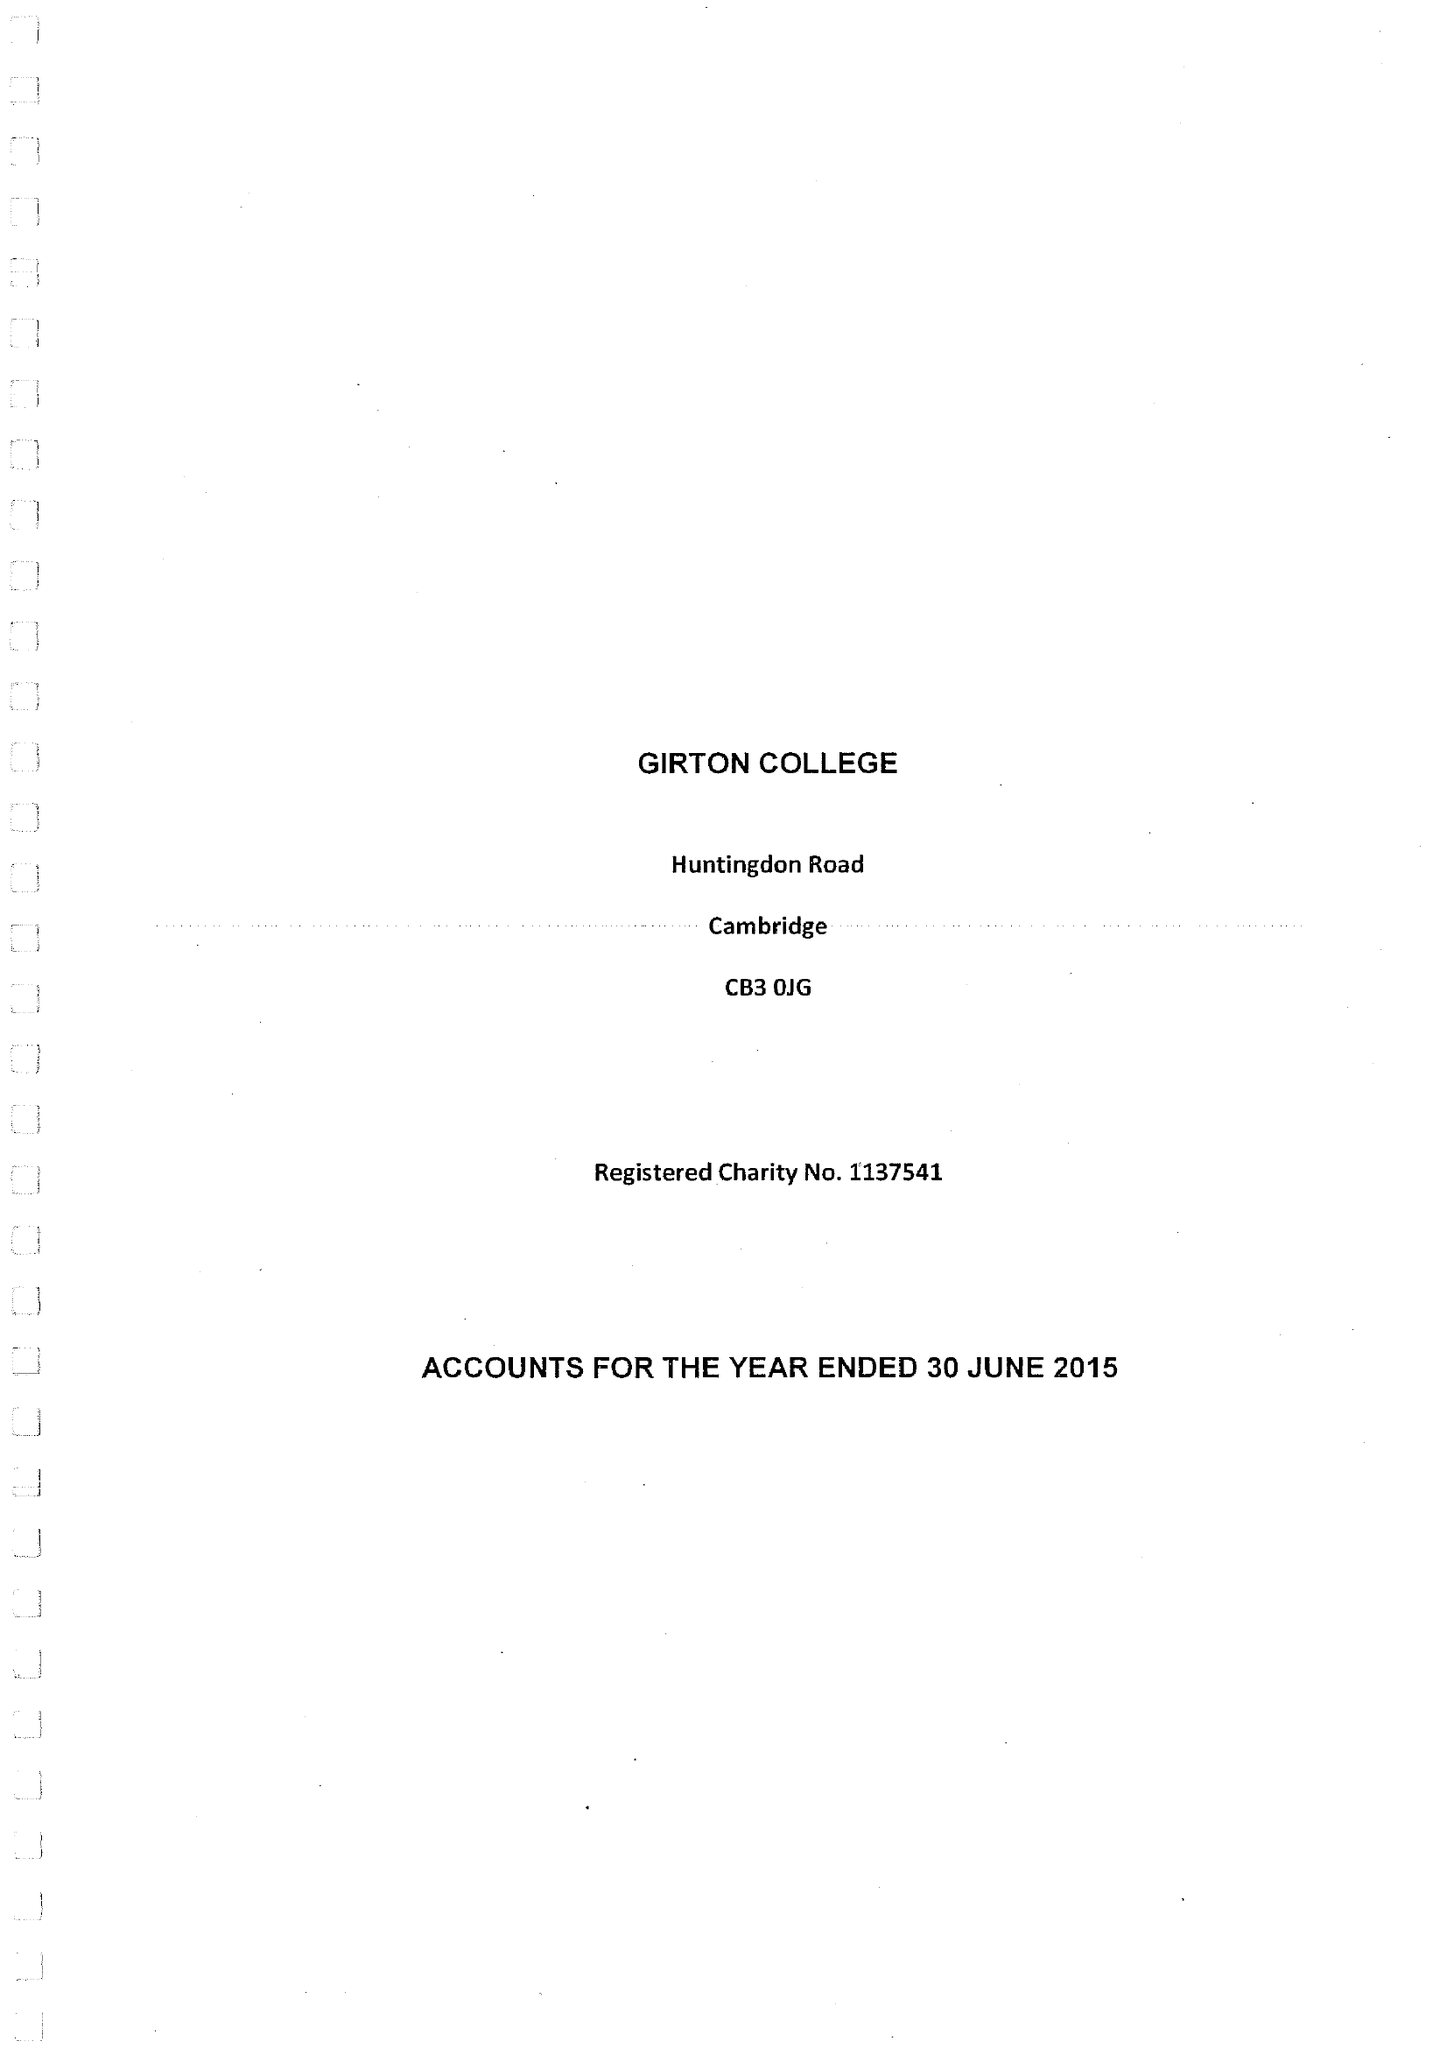What is the value for the report_date?
Answer the question using a single word or phrase. 2015-06-30 